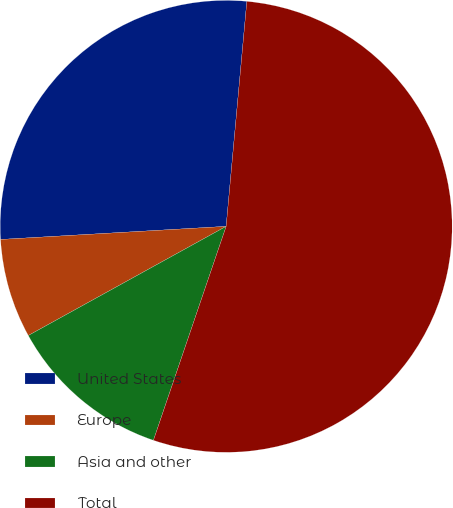<chart> <loc_0><loc_0><loc_500><loc_500><pie_chart><fcel>United States<fcel>Europe<fcel>Asia and other<fcel>Total<nl><fcel>27.38%<fcel>7.1%<fcel>11.76%<fcel>53.75%<nl></chart> 